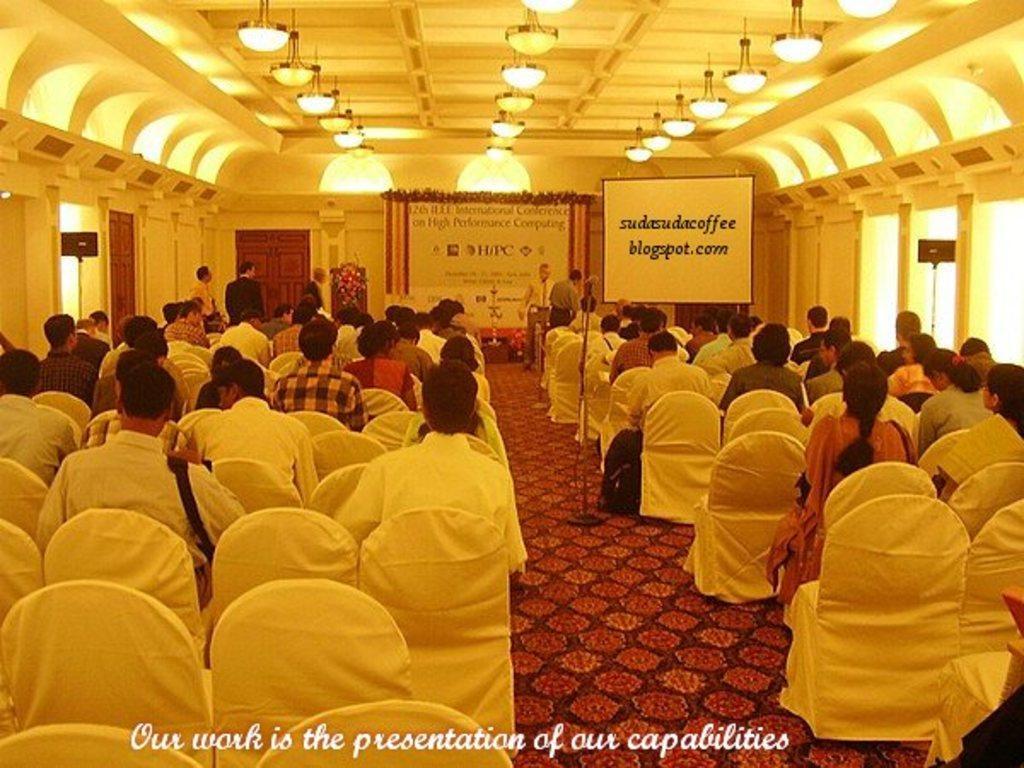How would you summarize this image in a sentence or two? In this image I can see number of people where few are standing and rest all are sitting on chairs. I can also see few boards, number of lights, watermark and on these boards I can see something is written. 